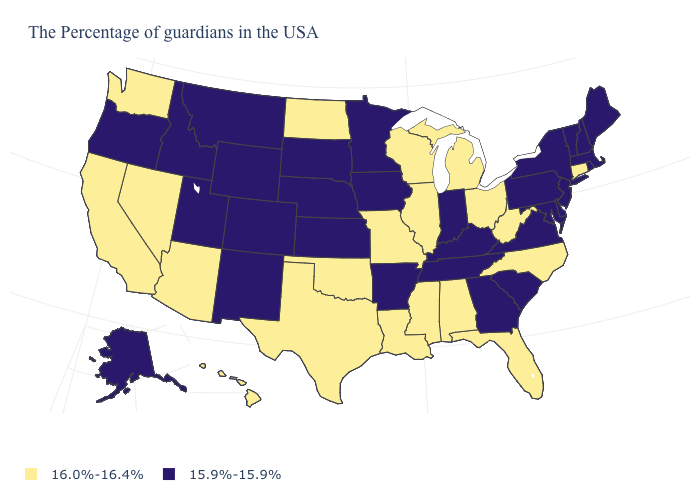What is the highest value in the West ?
Be succinct. 16.0%-16.4%. Which states hav the highest value in the MidWest?
Write a very short answer. Ohio, Michigan, Wisconsin, Illinois, Missouri, North Dakota. Does Alaska have a lower value than Florida?
Answer briefly. Yes. What is the highest value in the USA?
Concise answer only. 16.0%-16.4%. What is the value of Alabama?
Answer briefly. 16.0%-16.4%. Name the states that have a value in the range 16.0%-16.4%?
Write a very short answer. Connecticut, North Carolina, West Virginia, Ohio, Florida, Michigan, Alabama, Wisconsin, Illinois, Mississippi, Louisiana, Missouri, Oklahoma, Texas, North Dakota, Arizona, Nevada, California, Washington, Hawaii. Which states have the lowest value in the MidWest?
Write a very short answer. Indiana, Minnesota, Iowa, Kansas, Nebraska, South Dakota. What is the value of West Virginia?
Be succinct. 16.0%-16.4%. What is the value of New Jersey?
Short answer required. 15.9%-15.9%. What is the value of Kentucky?
Write a very short answer. 15.9%-15.9%. How many symbols are there in the legend?
Be succinct. 2. Does the first symbol in the legend represent the smallest category?
Give a very brief answer. No. Does Illinois have the same value as Florida?
Be succinct. Yes. What is the lowest value in the West?
Give a very brief answer. 15.9%-15.9%. Does Virginia have a higher value than Alabama?
Be succinct. No. 